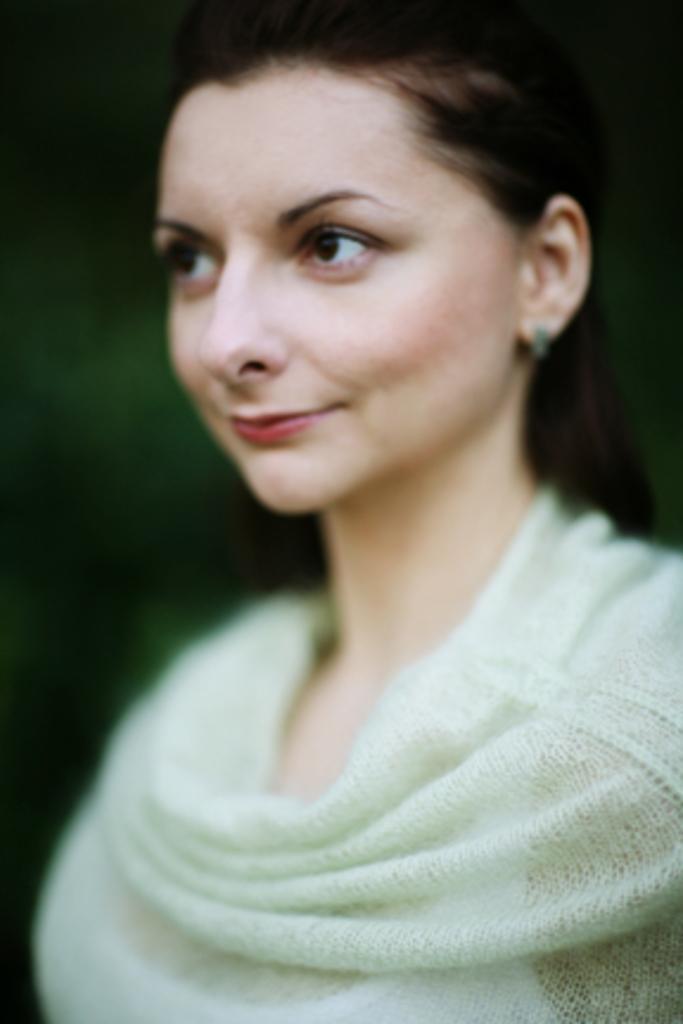In one or two sentences, can you explain what this image depicts? It is a picture of a smiling woman. The background is blue in green color. 